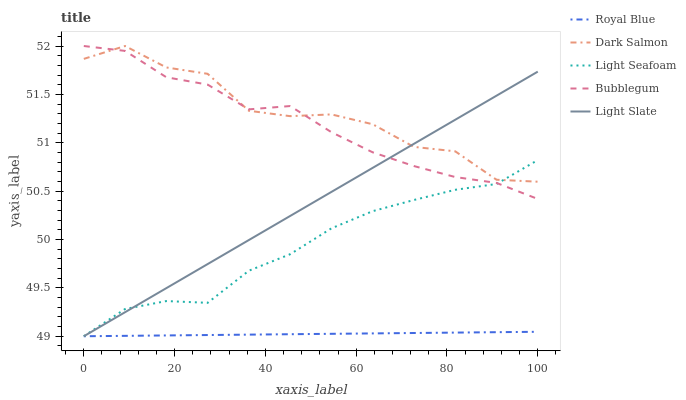Does Light Seafoam have the minimum area under the curve?
Answer yes or no. No. Does Light Seafoam have the maximum area under the curve?
Answer yes or no. No. Is Royal Blue the smoothest?
Answer yes or no. No. Is Royal Blue the roughest?
Answer yes or no. No. Does Dark Salmon have the lowest value?
Answer yes or no. No. Does Light Seafoam have the highest value?
Answer yes or no. No. Is Royal Blue less than Dark Salmon?
Answer yes or no. Yes. Is Bubblegum greater than Royal Blue?
Answer yes or no. Yes. Does Royal Blue intersect Dark Salmon?
Answer yes or no. No. 